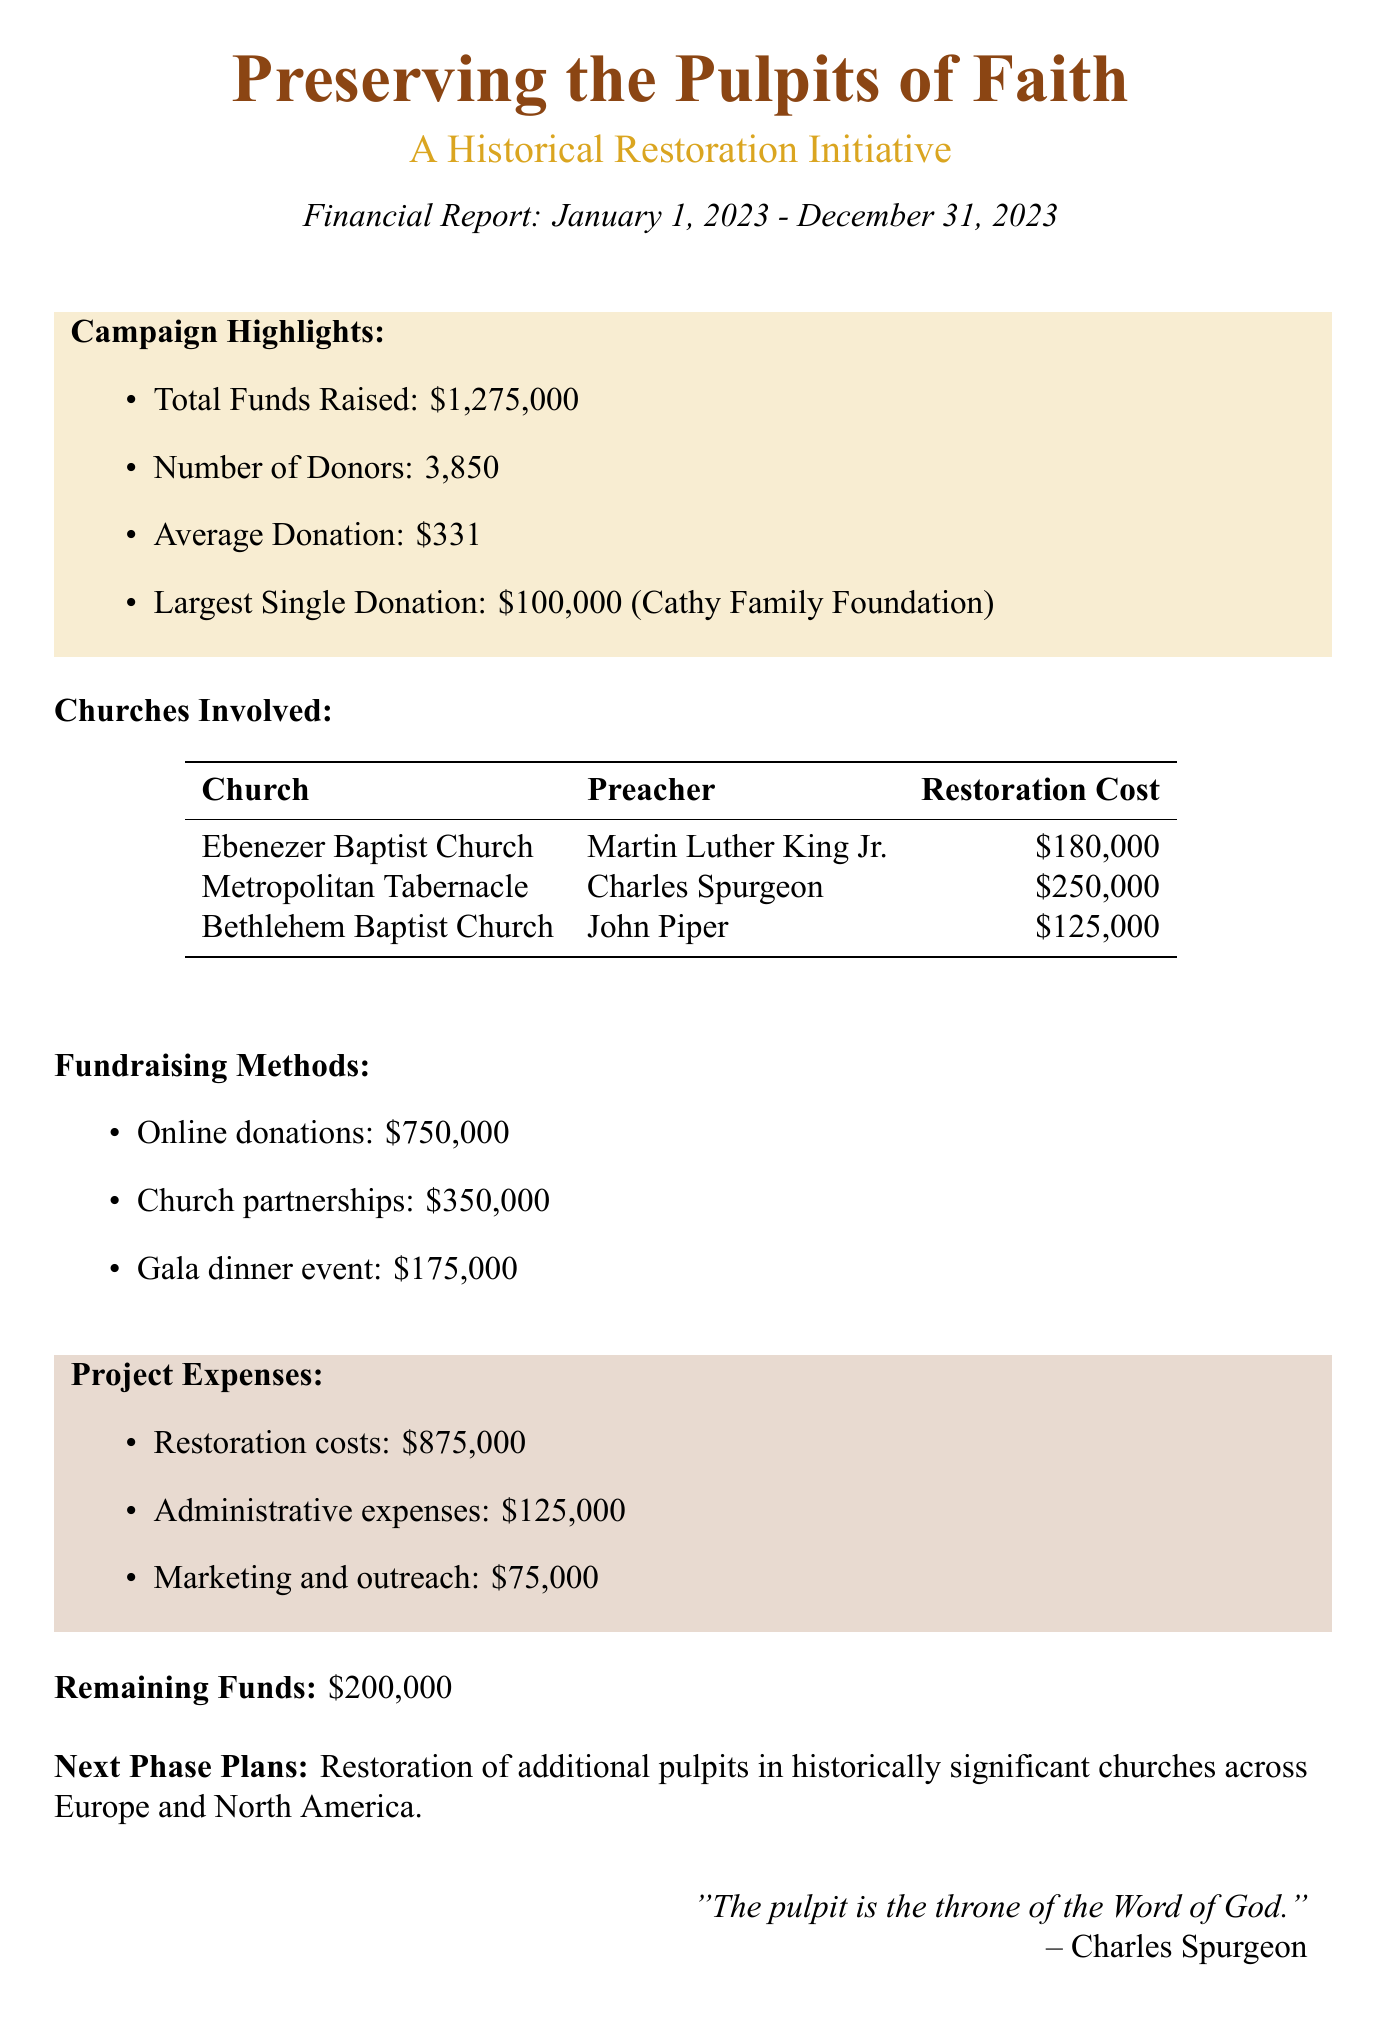What is the project title? The project title is explicitly stated in the document as "Preserving the Pulpits of Faith: A Historical Restoration Initiative."
Answer: Preserving the Pulpits of Faith: A Historical Restoration Initiative What is the total amount raised? The total amount raised is mentioned clearly as $1,275,000.
Answer: $1,275,000 How many churches are involved? The document lists three churches involved in the project.
Answer: 3 What was the average donation amount? The average donation amount is given as $331 in the document.
Answer: $331 Who made the largest single donation? The largest single donation was made by the Cathy Family Foundation, as stated in the document.
Answer: Cathy Family Foundation What are the total restoration costs? The total restoration costs are summed up as $875,000 in the project expenses section.
Answer: $875,000 How much was raised through online donations? The document specifies that online donations raised $750,000.
Answer: $750,000 What is the remaining fund after expenses? Remaining funds after expenses are indicated to be $200,000 in the report.
Answer: $200,000 What are the next phase plans? The next phase plans involve the restoration of additional pulpits in historically significant churches across Europe and North America.
Answer: Restoration of additional pulpits in historically significant churches across Europe and North America 